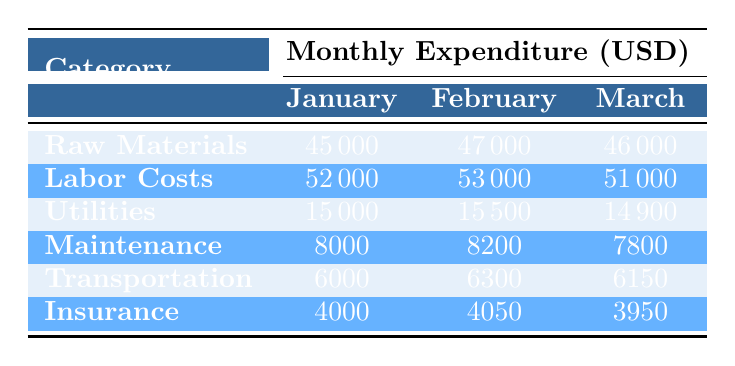What is the total expenditure on Raw Materials for the first three months? To find the total expenditure on Raw Materials, we sum the amounts for January, February, and March: 45000 + 47000 + 46000 = 138000.
Answer: 138000 Which month had the highest Labor Costs? Looking at the Labor Costs for each month, January had 52000, February had 53000, and March had 51000. The highest value is in February.
Answer: February Is the total expenditure on Utilities the same in January and March? The Utilities expenditure for January is 15000 and for March is 14900. Since they are not equal, the answer is no.
Answer: No What is the average monthly expenditure on Maintenance across the three months? The expenditures for Maintenance are 8000, 8200, and 7800. Summing these gives 8000 + 8200 + 7800 = 24000. Dividing by 3 gives an average of 24000 / 3 = 8000.
Answer: 8000 Did the Transportation costs increase every month? Observing the Transportation costs: January 6000, February 6300, and March 6150 shows that there was a decrease from February to March, so they did not increase every month.
Answer: No What is the total expenditure on Insurance across the three months? To find the total expenditure on Insurance, we sum the amounts for January, February, and March: 4000 + 4050 + 3950 = 12000.
Answer: 12000 Which category had the lowest expenditure in February? In February, the expenditures were: Raw Materials 47000, Labor Costs 53000, Utilities 15500, Maintenance 8200, Transportation 6300, and Insurance 4050. The lowest expenditure is in Insurance.
Answer: Insurance What is the total expenditure for all categories in March? To find the total for March, we sum all the expenditures: 46000 (Raw Materials) + 51000 (Labor Costs) + 14900 (Utilities) + 7800 (Maintenance) + 6150 (Transportation) + 3950 (Insurance) = 124800.
Answer: 124800 